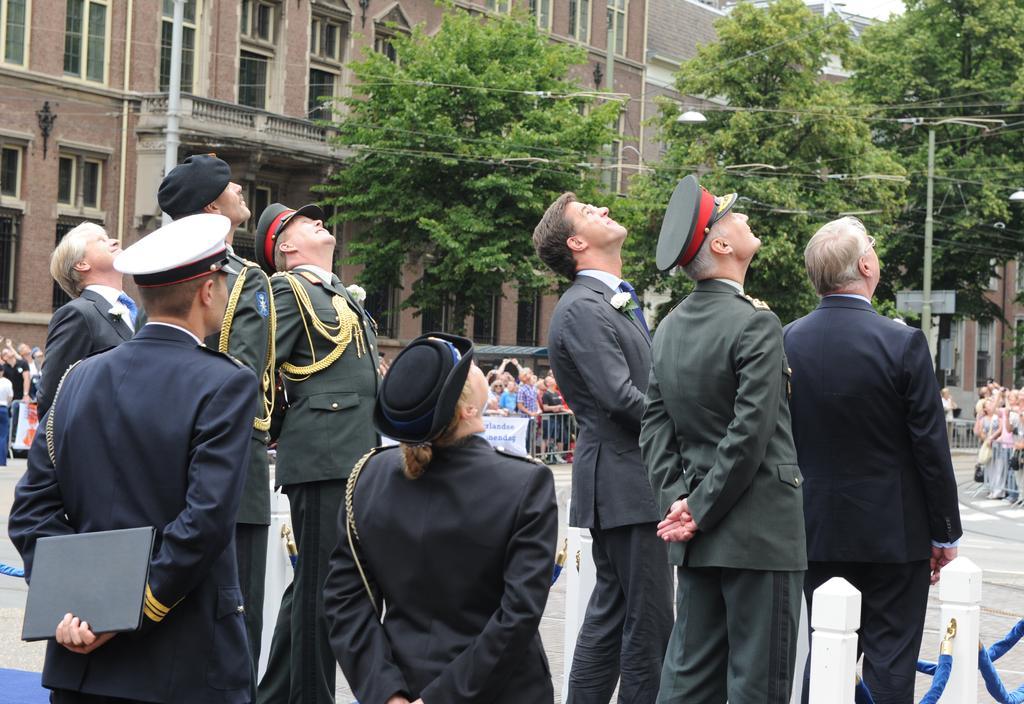In one or two sentences, can you explain what this image depicts? In this image, we can see a group of people are standing. Few are wearing caps. Left side of the image, we can see a person is holding com object. Background we can see poles, barricade, banners, few people, buildings, railings, walls, trees and road. 